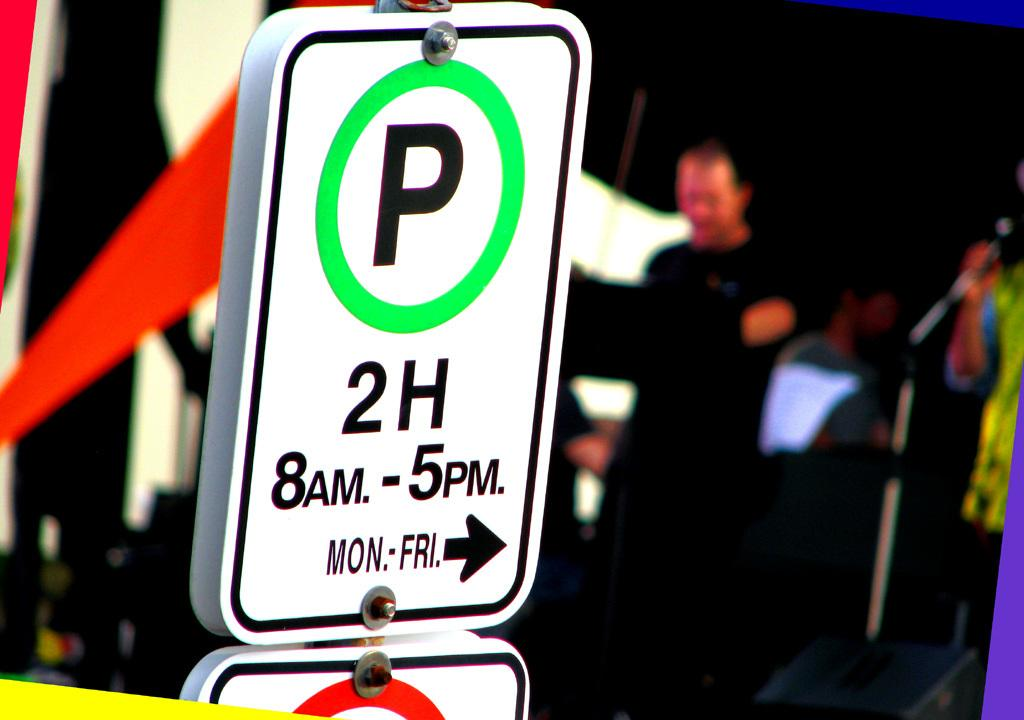<image>
Share a concise interpretation of the image provided. A parking sign advertising the 2 hour parking 